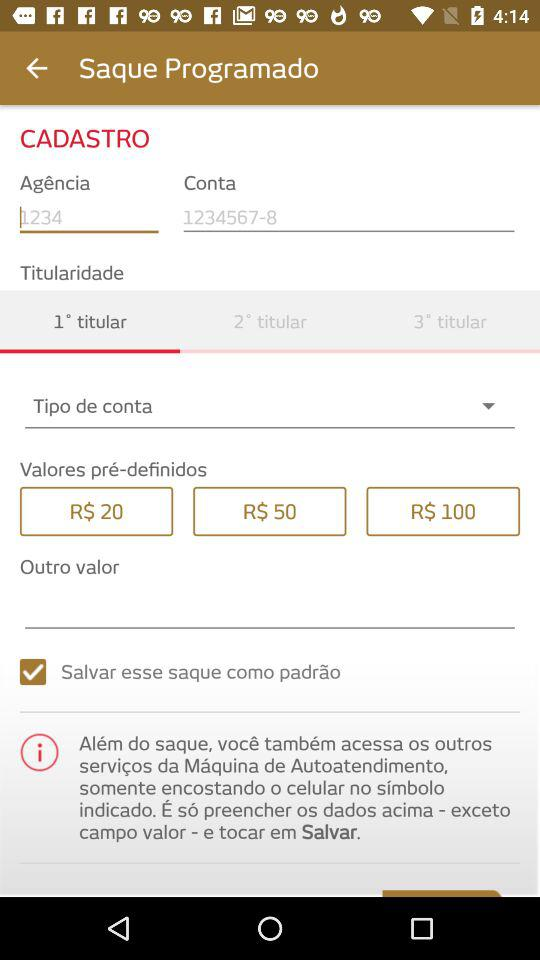How many values can be selected for the 'Tipo de conta' field?
Answer the question using a single word or phrase. 3 